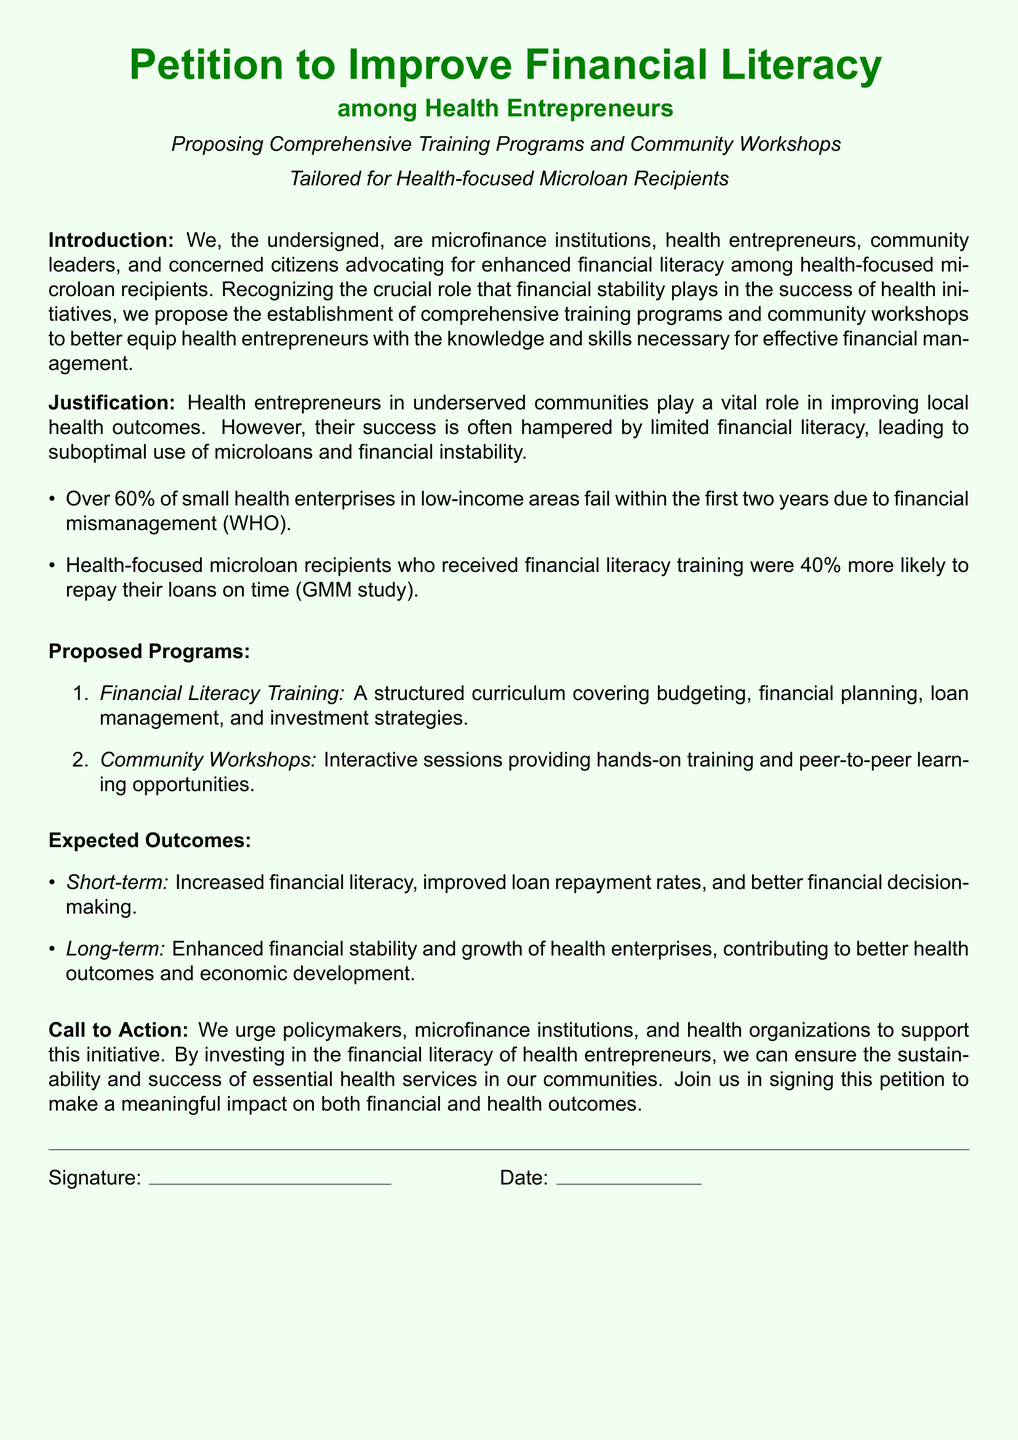What is the title of the petition? The title is prominently displayed at the top of the document as "Petition to Improve Financial Literacy".
Answer: Petition to Improve Financial Literacy Who are the primary advocates mentioned in the petition? The petition states that advocates include microfinance institutions, health entrepreneurs, community leaders, and concerned citizens.
Answer: microfinance institutions, health entrepreneurs, community leaders, and concerned citizens What percentage of small health enterprises fail within the first two years? The document mentions that over 60% of small health enterprises in low-income areas fail within that timeframe.
Answer: Over 60% What is one expected short-term outcome of the proposed programs? The expected outcomes section highlights increased financial literacy as a short-term outcome.
Answer: Increased financial literacy What type of training does the petition propose? It proposes a structured curriculum covering budgeting, financial planning, loan management, and investment strategies.
Answer: Financial Literacy Training What is the long-term expected impact of the initiative? The document states that the long-term impact is enhanced financial stability and growth of health enterprises.
Answer: Enhanced financial stability and growth of health enterprises What kind of sessions will the community workshops include? The community workshops are described as providing interactive sessions and peer-to-peer learning opportunities.
Answer: Interactive sessions What is the main call to action in the petition? The main call to action urges support from policymakers, microfinance institutions, and health organizations for the initiative.
Answer: Support this initiative How many programs are proposed in total? The "Proposed Programs" section lists two distinct programs.
Answer: Two programs 